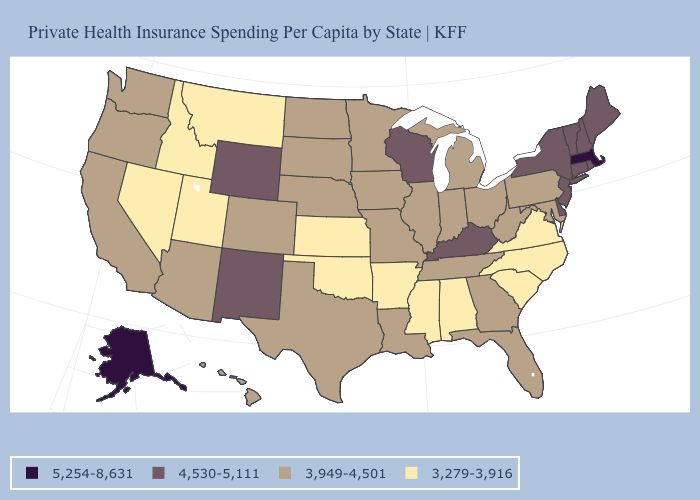Does Oregon have a lower value than Connecticut?
Short answer required. Yes. What is the lowest value in the West?
Concise answer only. 3,279-3,916. Name the states that have a value in the range 3,279-3,916?
Keep it brief. Alabama, Arkansas, Idaho, Kansas, Mississippi, Montana, Nevada, North Carolina, Oklahoma, South Carolina, Utah, Virginia. What is the value of South Dakota?
Concise answer only. 3,949-4,501. What is the highest value in the USA?
Concise answer only. 5,254-8,631. Among the states that border Pennsylvania , which have the lowest value?
Keep it brief. Maryland, Ohio, West Virginia. Among the states that border Vermont , which have the highest value?
Be succinct. Massachusetts. Does North Carolina have a lower value than Oregon?
Answer briefly. Yes. What is the value of Georgia?
Concise answer only. 3,949-4,501. Name the states that have a value in the range 4,530-5,111?
Give a very brief answer. Connecticut, Delaware, Kentucky, Maine, New Hampshire, New Jersey, New Mexico, New York, Rhode Island, Vermont, Wisconsin, Wyoming. What is the value of Alabama?
Concise answer only. 3,279-3,916. What is the value of Vermont?
Concise answer only. 4,530-5,111. Does the map have missing data?
Concise answer only. No. Does California have the lowest value in the West?
Answer briefly. No. Which states hav the highest value in the Northeast?
Write a very short answer. Massachusetts. 